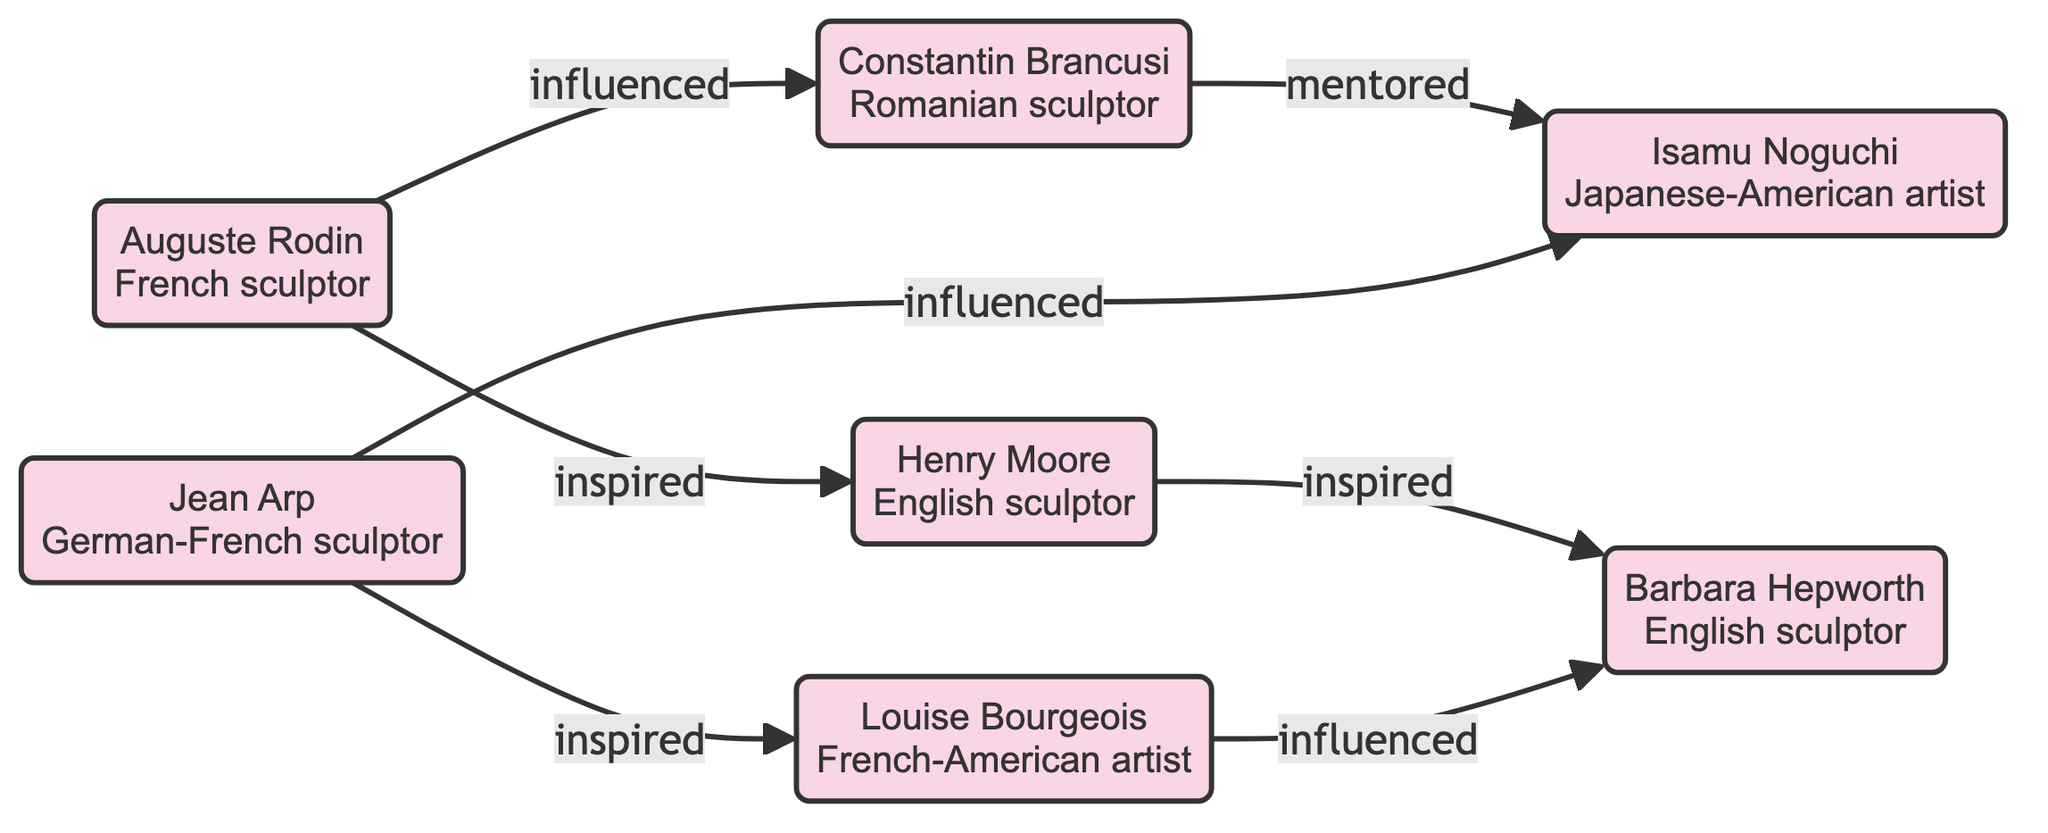How many nodes are in the diagram? The nodes in the diagram are Auguste Rodin, Constantin Brancusi, Henry Moore, Barbara Hepworth, Isamu Noguchi, Louise Bourgeois, and Jean Arp. Counting these gives a total of 7 nodes.
Answer: 7 Who influenced Constantin Brancusi? The diagram shows an arrow pointing from Auguste Rodin to Constantin Brancusi, labeled "influenced." Therefore, Auguste Rodin is the one who influenced him.
Answer: Auguste Rodin Which sculptor was mentored by Constantin Brancusi? The diagram shows an arrow going from Constantin Brancusi to Isamu Noguchi, labeled "mentored." This indicates that Isamu Noguchi was mentored by Constantin Brancusi.
Answer: Isamu Noguchi Who inspired Barbara Hepworth? According to the diagram, Barbara Hepworth has an arrow pointing towards her from Henry Moore, labeled "inspired," and also an arrow from Louise Bourgeois, labeled "influenced." This means that both Henry Moore and Louise Bourgeois inspired Barbara Hepworth.
Answer: Henry Moore, Louise Bourgeois Which artist is influenced by both Jean Arp and Constantin Brancusi? The diagram has an arrow labeled "influenced" going from both Jean Arp to Isamu Noguchi, and also another directed edge from Constantin Brancusi to Isamu Noguchi, indicating that Isamu Noguchi is influenced by both artists.
Answer: Isamu Noguchi Which pair of sculptors has a direct relationship defined as "inspired"? The diagram illustrates a direct relationship where Henry Moore is connected to Barbara Hepworth through the label "inspired," indicating that Henry Moore inspires Barbara Hepworth.
Answer: Henry Moore, Barbara Hepworth How many edges are shown in the diagram? By counting the arrows or edges connecting the nodes, we see there are 7 edges in total.
Answer: 7 Which sculptor has the most influences labeled as "inspired"? Analyzing the diagram, Jean Arp influences Louise Bourgeois and has an edge labeled "inspired," while Henry Moore inspires Barbara Hepworth. However, Jean Arp is connected to two artists (Isamu Noguchi and Louise Bourgeois) while others are connected to fewer. This makes Jean Arp the sculptor with multiple "inspired" connections.
Answer: Jean Arp 